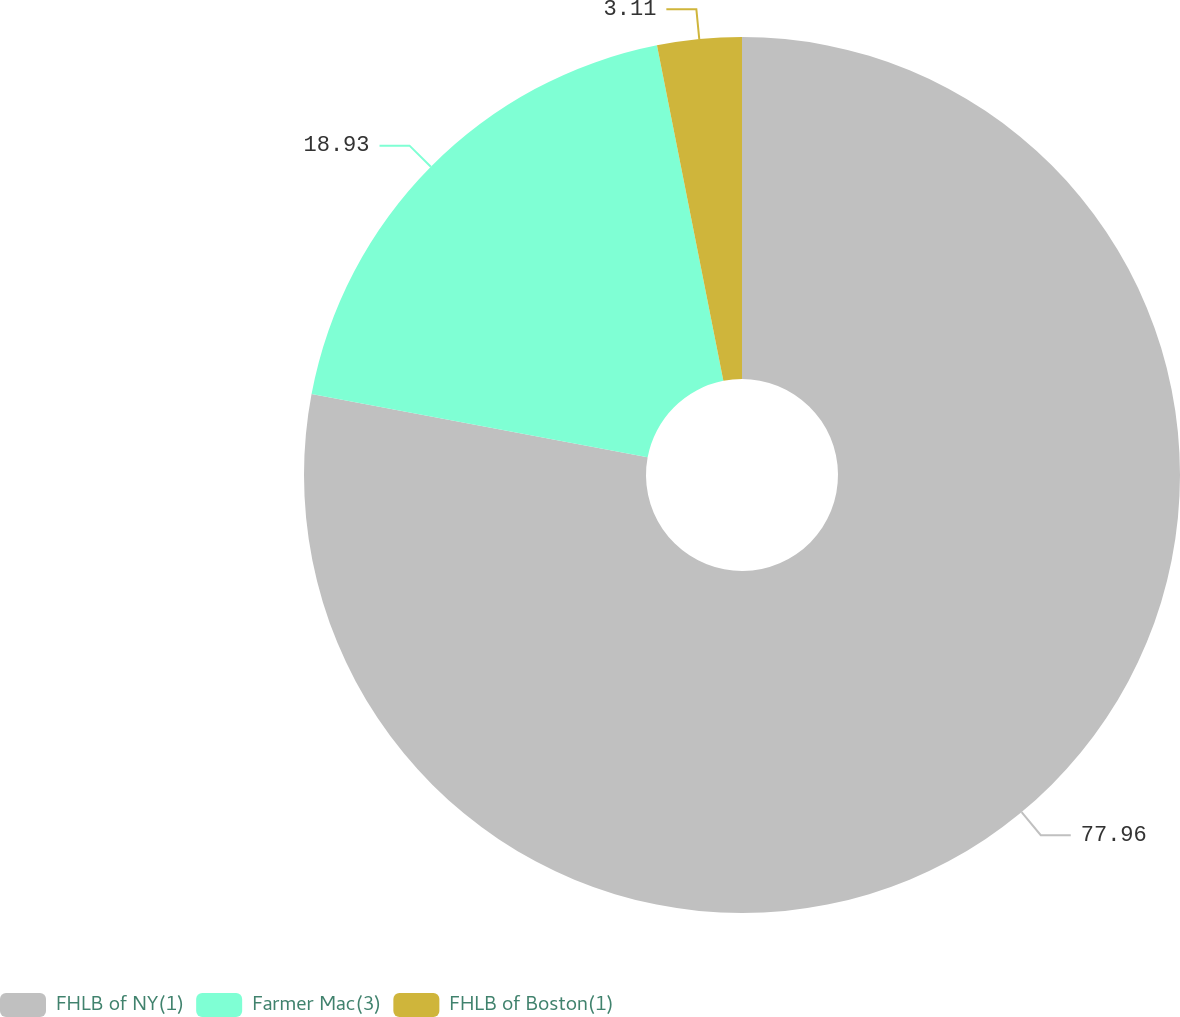Convert chart. <chart><loc_0><loc_0><loc_500><loc_500><pie_chart><fcel>FHLB of NY(1)<fcel>Farmer Mac(3)<fcel>FHLB of Boston(1)<nl><fcel>77.96%<fcel>18.93%<fcel>3.11%<nl></chart> 